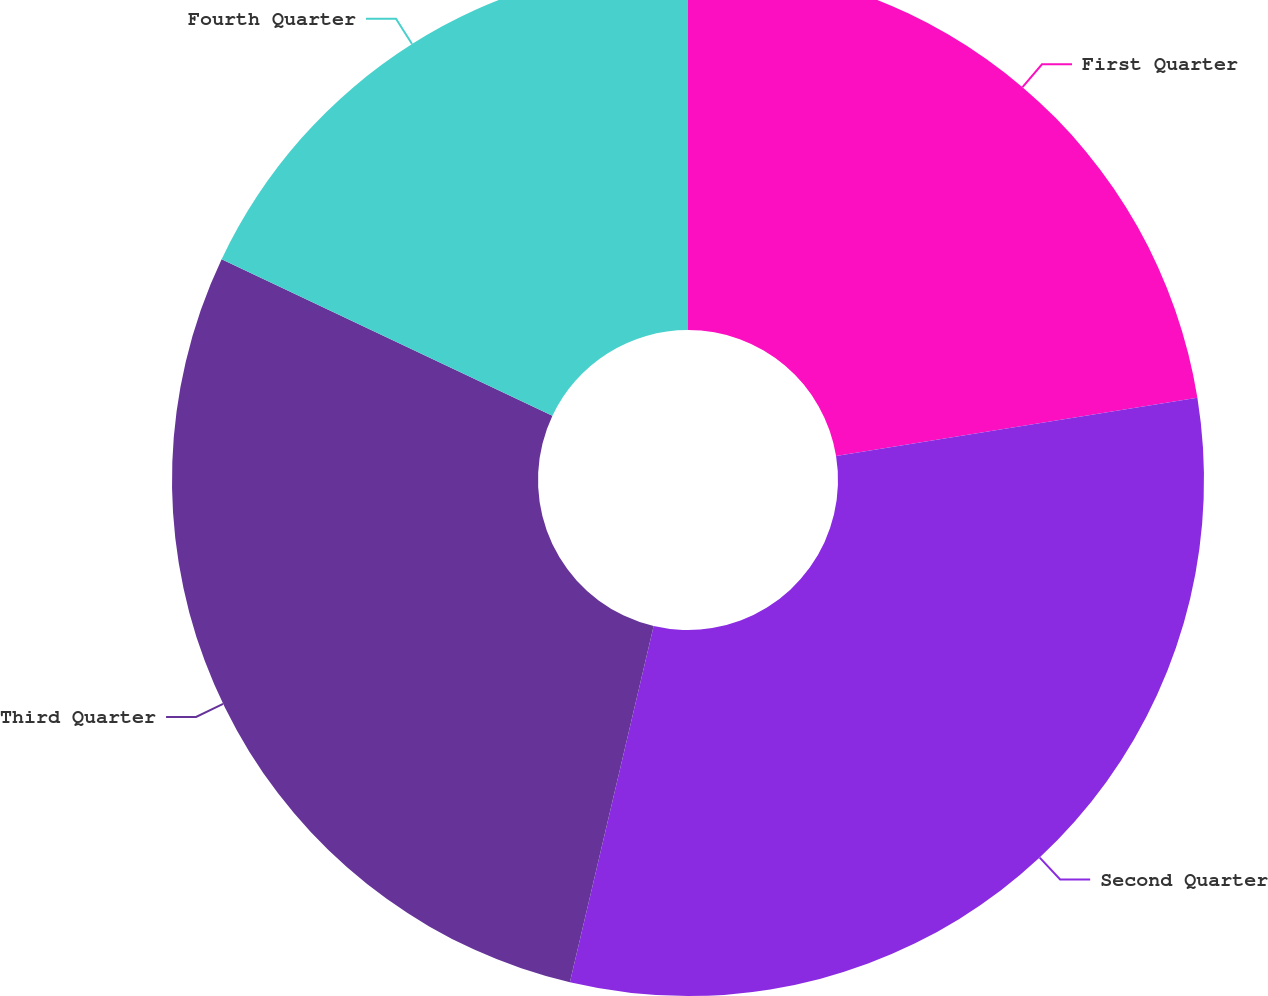Convert chart. <chart><loc_0><loc_0><loc_500><loc_500><pie_chart><fcel>First Quarter<fcel>Second Quarter<fcel>Third Quarter<fcel>Fourth Quarter<nl><fcel>22.45%<fcel>31.22%<fcel>28.36%<fcel>17.96%<nl></chart> 